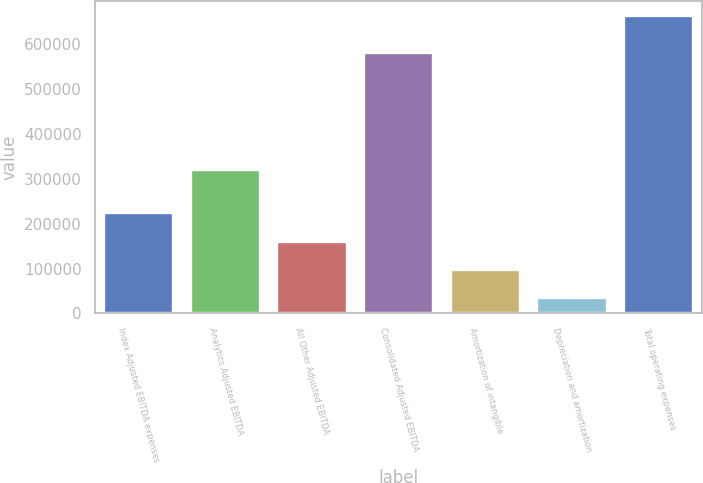Convert chart. <chart><loc_0><loc_0><loc_500><loc_500><bar_chart><fcel>Index Adjusted EBITDA expenses<fcel>Analytics Adjusted EBITDA<fcel>All Other Adjusted EBITDA<fcel>Consolidated Adjusted EBITDA<fcel>Amortization of intangible<fcel>Depreciation and amortization<fcel>Total operating expenses<nl><fcel>222794<fcel>319846<fcel>159969<fcel>581212<fcel>97144.5<fcel>34320<fcel>662565<nl></chart> 